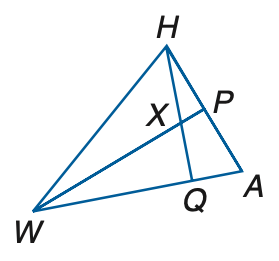Answer the mathemtical geometry problem and directly provide the correct option letter.
Question: If W P is a perpendicular bisector, m \angle W H A = 8 q + 17, m \angle H W P = 10 + q, A P = 6 r + 4, and P H = 22 + 3 r, find m \angle H W P.
Choices: A: 15 B: 16 C: 17 D: 18 C 